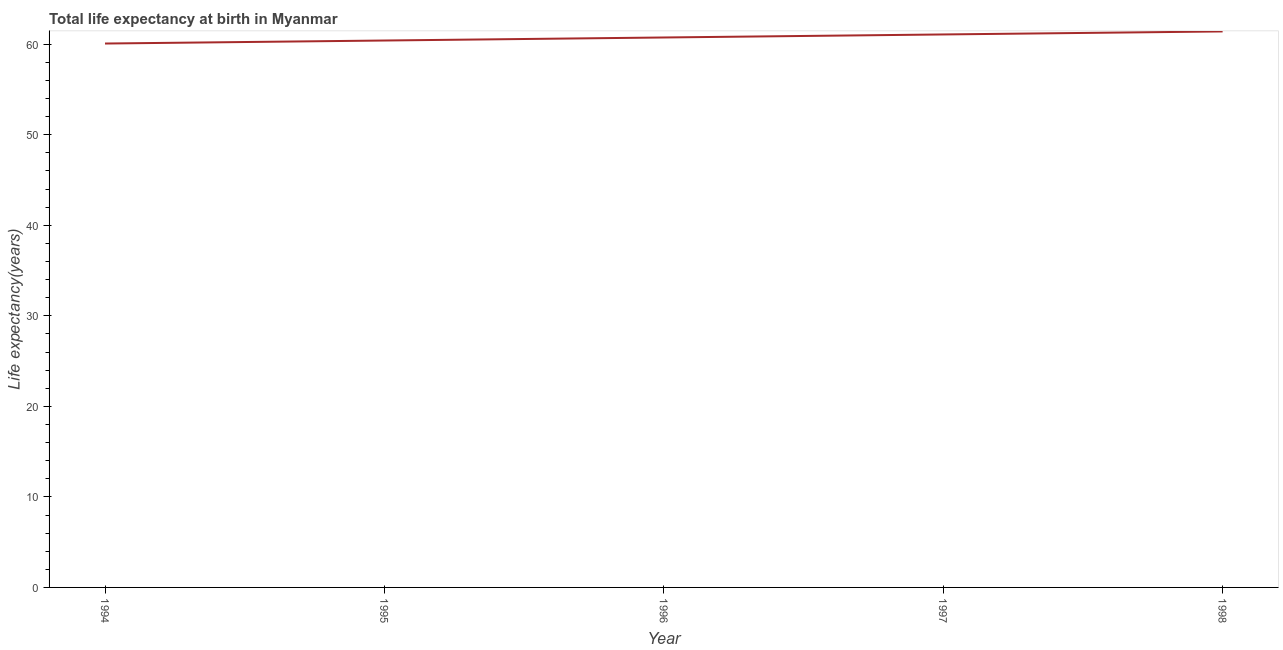What is the life expectancy at birth in 1997?
Offer a very short reply. 61.08. Across all years, what is the maximum life expectancy at birth?
Provide a succinct answer. 61.41. Across all years, what is the minimum life expectancy at birth?
Your answer should be compact. 60.08. In which year was the life expectancy at birth maximum?
Offer a terse response. 1998. What is the sum of the life expectancy at birth?
Your answer should be very brief. 303.73. What is the difference between the life expectancy at birth in 1997 and 1998?
Offer a terse response. -0.33. What is the average life expectancy at birth per year?
Ensure brevity in your answer.  60.75. What is the median life expectancy at birth?
Your answer should be very brief. 60.75. What is the ratio of the life expectancy at birth in 1995 to that in 1998?
Your response must be concise. 0.98. Is the life expectancy at birth in 1994 less than that in 1997?
Provide a succinct answer. Yes. Is the difference between the life expectancy at birth in 1994 and 1997 greater than the difference between any two years?
Make the answer very short. No. What is the difference between the highest and the second highest life expectancy at birth?
Give a very brief answer. 0.33. Is the sum of the life expectancy at birth in 1994 and 1995 greater than the maximum life expectancy at birth across all years?
Ensure brevity in your answer.  Yes. What is the difference between the highest and the lowest life expectancy at birth?
Make the answer very short. 1.34. In how many years, is the life expectancy at birth greater than the average life expectancy at birth taken over all years?
Provide a short and direct response. 3. Are the values on the major ticks of Y-axis written in scientific E-notation?
Provide a short and direct response. No. Does the graph contain any zero values?
Ensure brevity in your answer.  No. Does the graph contain grids?
Offer a terse response. No. What is the title of the graph?
Keep it short and to the point. Total life expectancy at birth in Myanmar. What is the label or title of the X-axis?
Keep it short and to the point. Year. What is the label or title of the Y-axis?
Your answer should be compact. Life expectancy(years). What is the Life expectancy(years) in 1994?
Provide a succinct answer. 60.08. What is the Life expectancy(years) of 1995?
Offer a very short reply. 60.41. What is the Life expectancy(years) of 1996?
Provide a succinct answer. 60.75. What is the Life expectancy(years) in 1997?
Your answer should be very brief. 61.08. What is the Life expectancy(years) in 1998?
Your answer should be compact. 61.41. What is the difference between the Life expectancy(years) in 1994 and 1995?
Provide a short and direct response. -0.33. What is the difference between the Life expectancy(years) in 1994 and 1996?
Your answer should be very brief. -0.67. What is the difference between the Life expectancy(years) in 1994 and 1997?
Provide a short and direct response. -1. What is the difference between the Life expectancy(years) in 1994 and 1998?
Ensure brevity in your answer.  -1.34. What is the difference between the Life expectancy(years) in 1995 and 1996?
Your response must be concise. -0.33. What is the difference between the Life expectancy(years) in 1995 and 1997?
Your response must be concise. -0.67. What is the difference between the Life expectancy(years) in 1995 and 1998?
Offer a very short reply. -1. What is the difference between the Life expectancy(years) in 1996 and 1997?
Provide a succinct answer. -0.33. What is the difference between the Life expectancy(years) in 1996 and 1998?
Keep it short and to the point. -0.67. What is the difference between the Life expectancy(years) in 1997 and 1998?
Provide a succinct answer. -0.33. What is the ratio of the Life expectancy(years) in 1994 to that in 1996?
Make the answer very short. 0.99. What is the ratio of the Life expectancy(years) in 1994 to that in 1997?
Your answer should be very brief. 0.98. What is the ratio of the Life expectancy(years) in 1994 to that in 1998?
Your answer should be compact. 0.98. What is the ratio of the Life expectancy(years) in 1995 to that in 1997?
Give a very brief answer. 0.99. What is the ratio of the Life expectancy(years) in 1995 to that in 1998?
Your answer should be very brief. 0.98. What is the ratio of the Life expectancy(years) in 1997 to that in 1998?
Give a very brief answer. 0.99. 